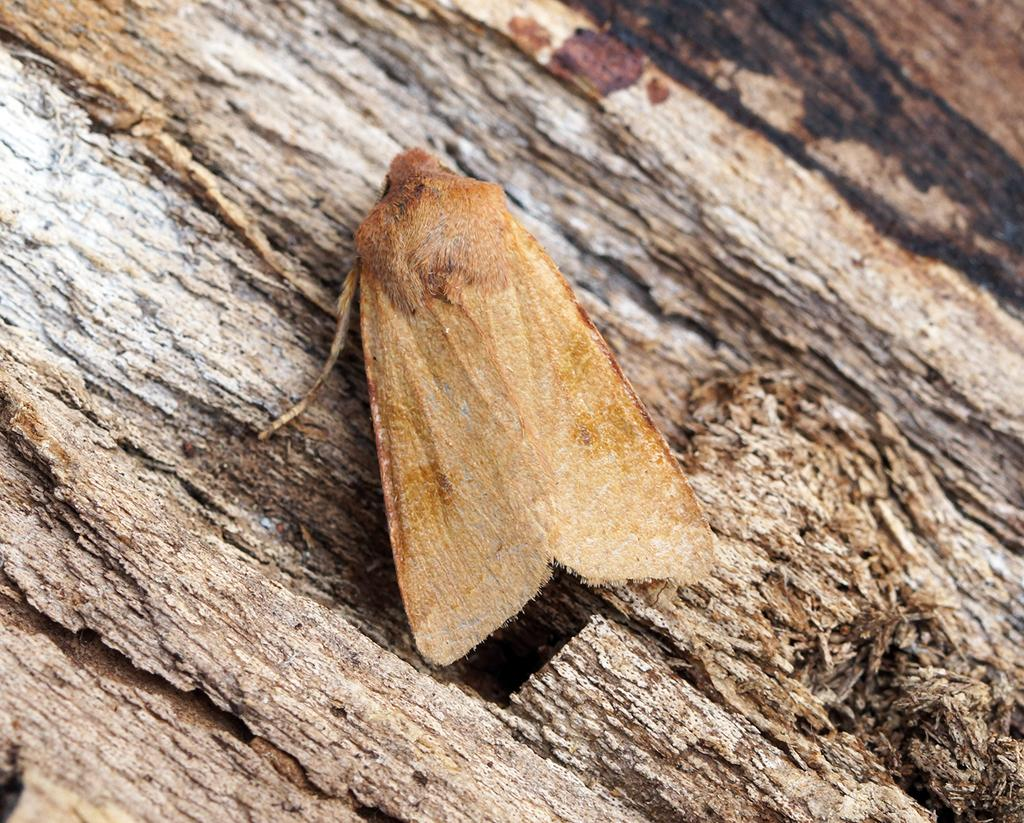What is present in the image? There is an insect in the image. Where is the insect located? The insect is on a tree trunk. What type of ball is being used in the hospital in the image? There is no ball or hospital present in the image; it only features an insect on a tree trunk. 